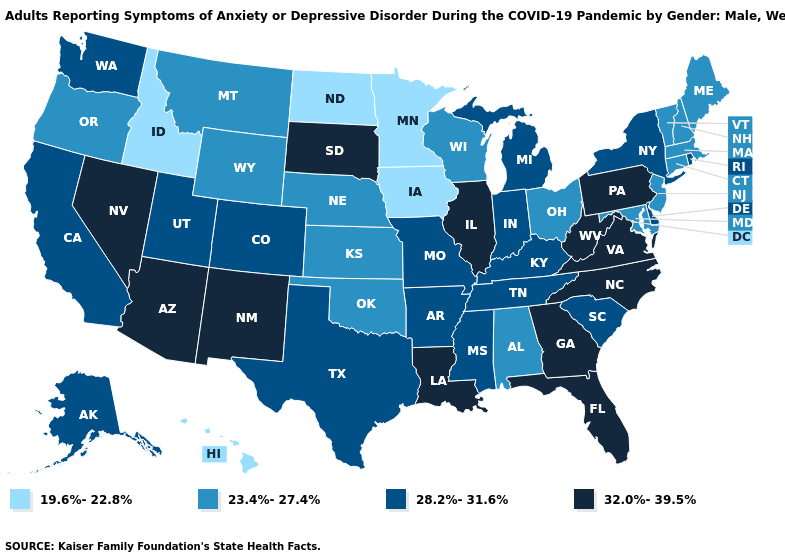Name the states that have a value in the range 19.6%-22.8%?
Quick response, please. Hawaii, Idaho, Iowa, Minnesota, North Dakota. Does the first symbol in the legend represent the smallest category?
Answer briefly. Yes. Does Michigan have the lowest value in the USA?
Answer briefly. No. What is the value of North Carolina?
Be succinct. 32.0%-39.5%. Is the legend a continuous bar?
Answer briefly. No. What is the value of Massachusetts?
Answer briefly. 23.4%-27.4%. Name the states that have a value in the range 32.0%-39.5%?
Short answer required. Arizona, Florida, Georgia, Illinois, Louisiana, Nevada, New Mexico, North Carolina, Pennsylvania, South Dakota, Virginia, West Virginia. Is the legend a continuous bar?
Quick response, please. No. Name the states that have a value in the range 23.4%-27.4%?
Be succinct. Alabama, Connecticut, Kansas, Maine, Maryland, Massachusetts, Montana, Nebraska, New Hampshire, New Jersey, Ohio, Oklahoma, Oregon, Vermont, Wisconsin, Wyoming. What is the value of Maine?
Write a very short answer. 23.4%-27.4%. Name the states that have a value in the range 23.4%-27.4%?
Quick response, please. Alabama, Connecticut, Kansas, Maine, Maryland, Massachusetts, Montana, Nebraska, New Hampshire, New Jersey, Ohio, Oklahoma, Oregon, Vermont, Wisconsin, Wyoming. What is the value of Mississippi?
Quick response, please. 28.2%-31.6%. What is the value of Pennsylvania?
Write a very short answer. 32.0%-39.5%. Among the states that border Wisconsin , which have the lowest value?
Concise answer only. Iowa, Minnesota. Name the states that have a value in the range 28.2%-31.6%?
Concise answer only. Alaska, Arkansas, California, Colorado, Delaware, Indiana, Kentucky, Michigan, Mississippi, Missouri, New York, Rhode Island, South Carolina, Tennessee, Texas, Utah, Washington. 